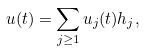<formula> <loc_0><loc_0><loc_500><loc_500>u ( t ) = \sum _ { j \geq 1 } u _ { j } ( t ) h _ { j } ,</formula> 